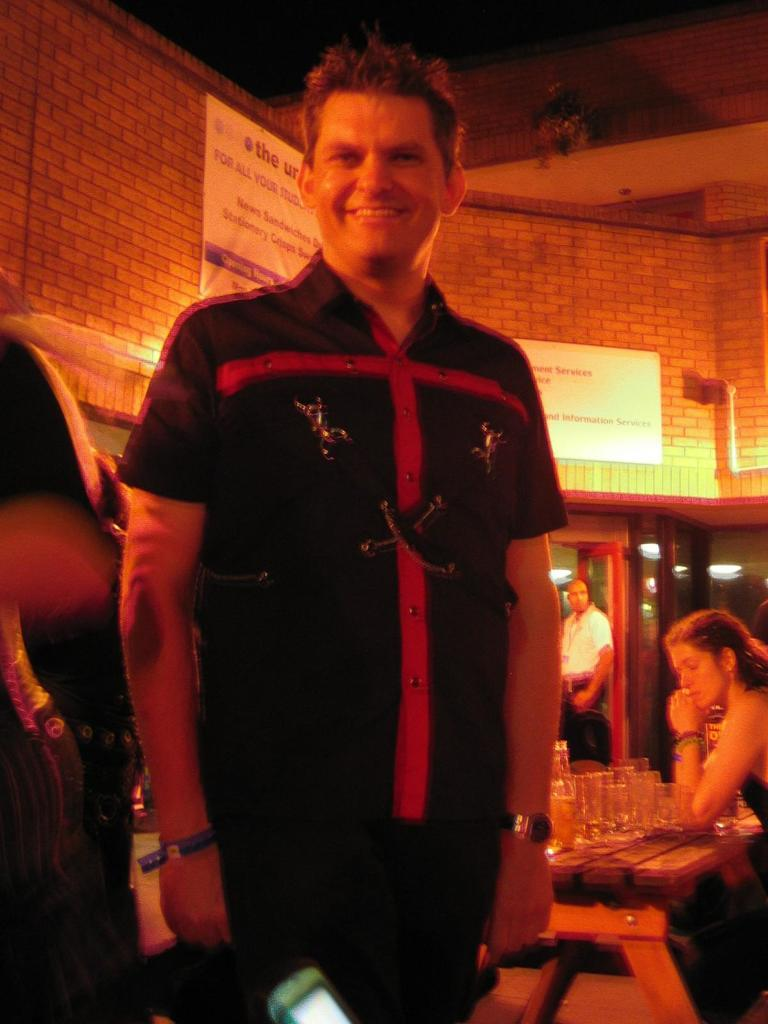What is the man in the image doing? The man is smiling in the image. What is the man wearing? The man is wearing a shirt and trousers in the image. What accessory is the man wearing? The man is wearing a watch in the image. Who is on the right side of the image? There is a woman on the right side of the image. What objects are present in the image related to drinking? There are wine glasses in the image. What is behind the man in the image? There is a wall behind the man in the image. What type of playground equipment can be seen in the image? There is no playground equipment present in the image. Who is the grandfather in the image? There is no mention of a grandfather in the image. 